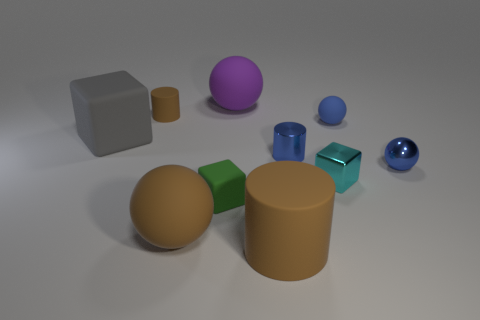Subtract all cubes. How many objects are left? 7 Add 1 purple shiny cubes. How many purple shiny cubes exist? 1 Subtract 0 gray cylinders. How many objects are left? 10 Subtract all small blue matte balls. Subtract all cylinders. How many objects are left? 6 Add 5 shiny objects. How many shiny objects are left? 8 